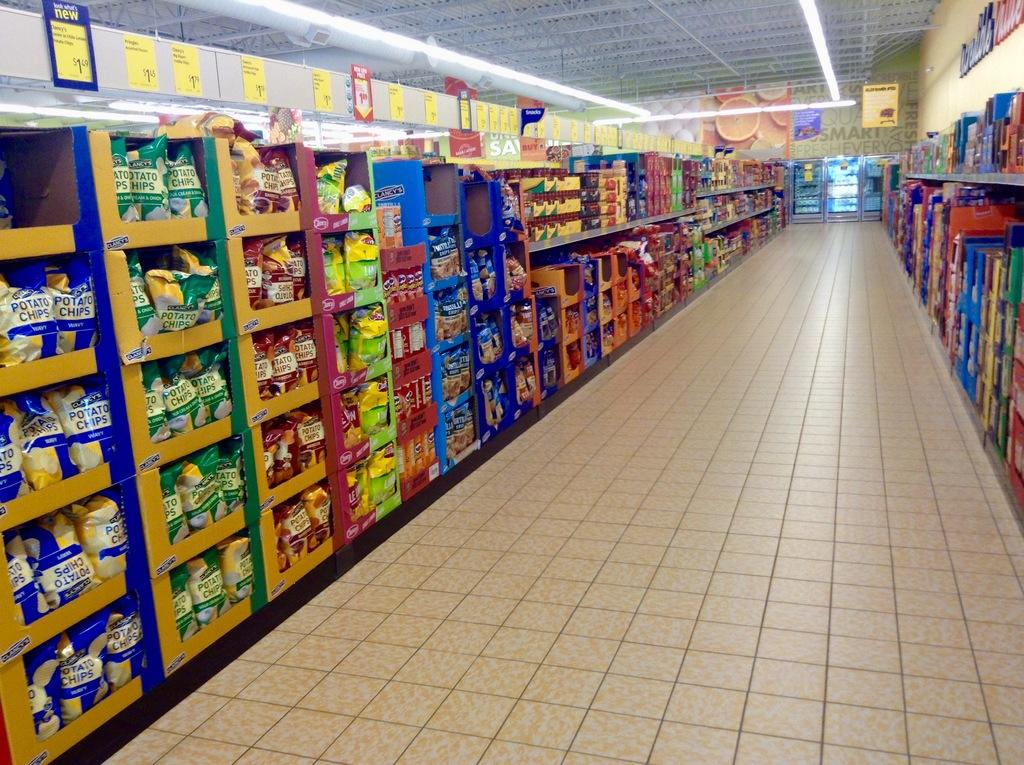What type of surface is visible in the image? The image contains a floor. What type of storage or display feature can be seen in the image? There are shelves in the image. What items are present on the shelves? There are packets and stickers in the image. What can be seen in the background of the image? There is a wall, lights, and a roof in the background of the image. What type of fruit is being served at the event in the image? There is no event or fruit present in the image; it contains shelves with packets and stickers. 